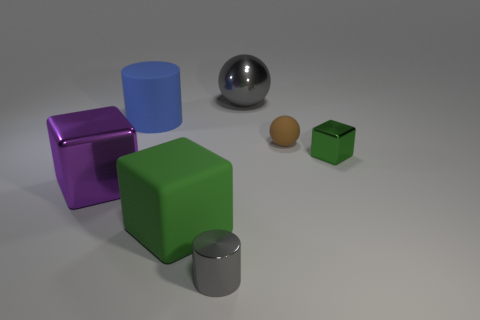How many green cubes must be subtracted to get 1 green cubes? 1 Subtract all metallic cubes. How many cubes are left? 1 Add 3 cyan matte objects. How many objects exist? 10 Subtract all purple blocks. How many blocks are left? 2 Subtract all brown cylinders. How many green cubes are left? 2 Subtract all cubes. How many objects are left? 4 Subtract 2 cubes. How many cubes are left? 1 Subtract all gray blocks. Subtract all green cylinders. How many blocks are left? 3 Subtract all gray cylinders. Subtract all green metallic things. How many objects are left? 5 Add 6 small green cubes. How many small green cubes are left? 7 